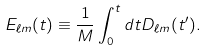<formula> <loc_0><loc_0><loc_500><loc_500>E _ { \ell m } ( t ) \equiv \frac { 1 } { M } \int _ { 0 } ^ { t } { d t D _ { \ell m } ( t ^ { \prime } ) } .</formula> 